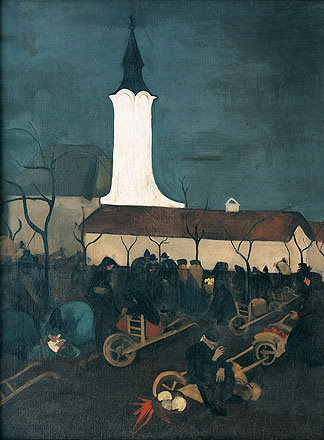Can you describe the mood conveyed in the painting and how it is achieved? The painting conveys a somber and reflective mood, achieved through the use of dark, muted color palettes and subtle interactions among the figures. The overcast sky and the shadowy outlines of the trees and people contribute to a feeling of introspection or solemnity, possibly indicating a time of gathering or remembrance in the village life. The centralized position of the church's white steeple acts as a beacon, guiding the viewer's eye and adding a sense of hope or spiritual elevation amidst the somber tones. 